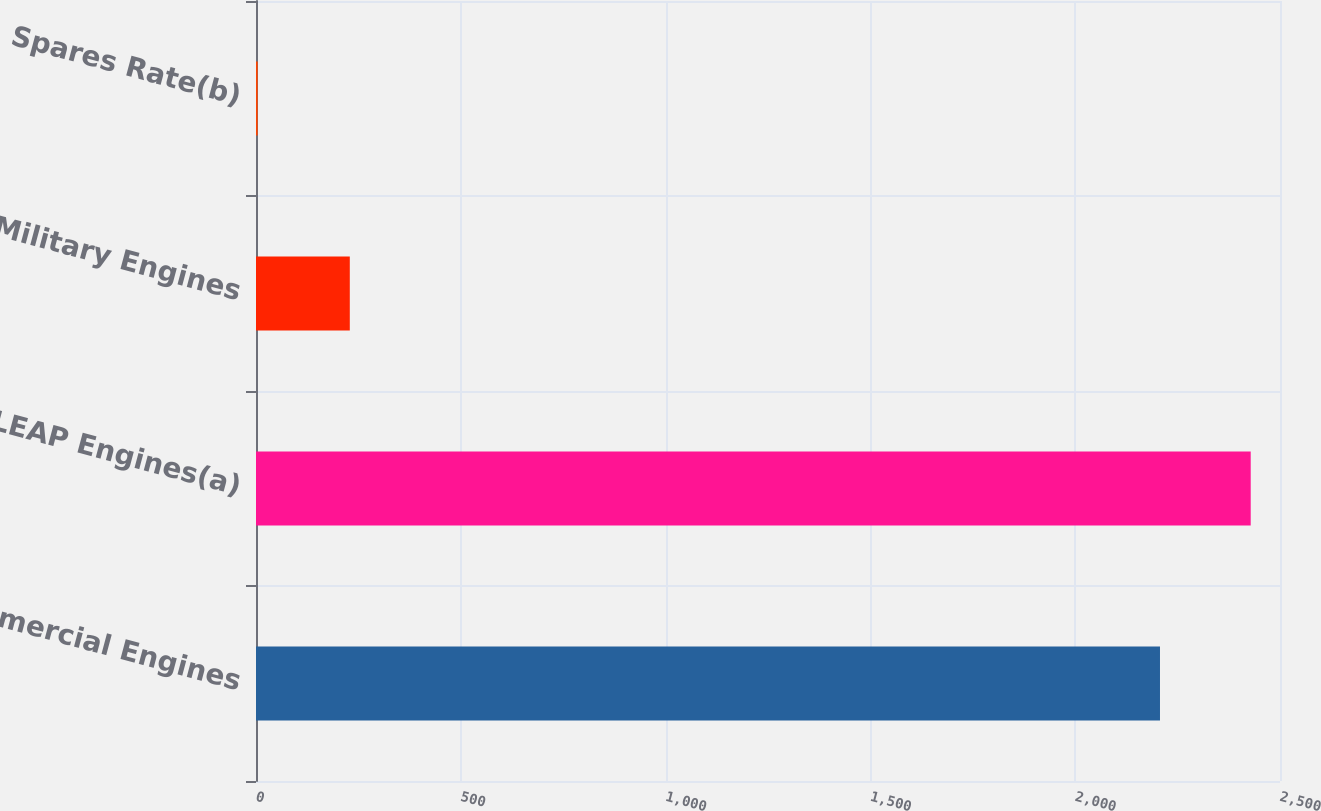Convert chart to OTSL. <chart><loc_0><loc_0><loc_500><loc_500><bar_chart><fcel>Commercial Engines<fcel>LEAP Engines(a)<fcel>Military Engines<fcel>Spares Rate(b)<nl><fcel>2207<fcel>2428.5<fcel>229<fcel>4<nl></chart> 